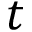<formula> <loc_0><loc_0><loc_500><loc_500>t</formula> 